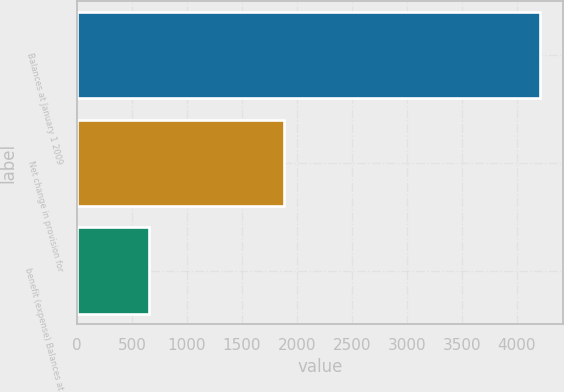<chart> <loc_0><loc_0><loc_500><loc_500><bar_chart><fcel>Balances at January 1 2009<fcel>Net change in provision for<fcel>benefit (expense) Balances at<nl><fcel>4208<fcel>1884.3<fcel>654.8<nl></chart> 